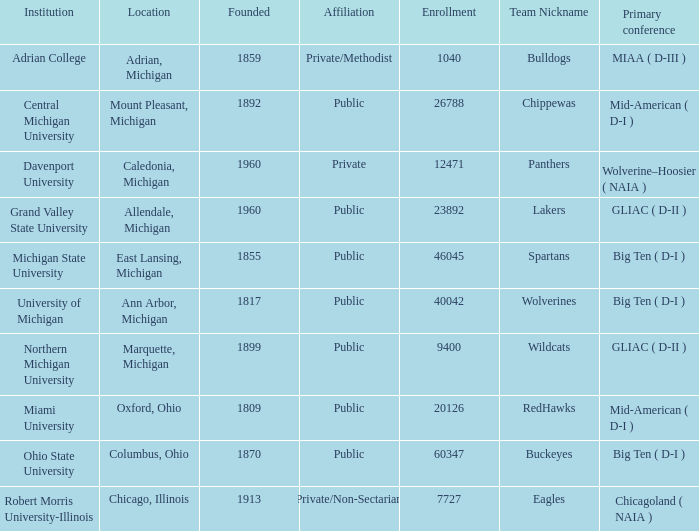What is the enrollment for the Redhawks? 1.0. 